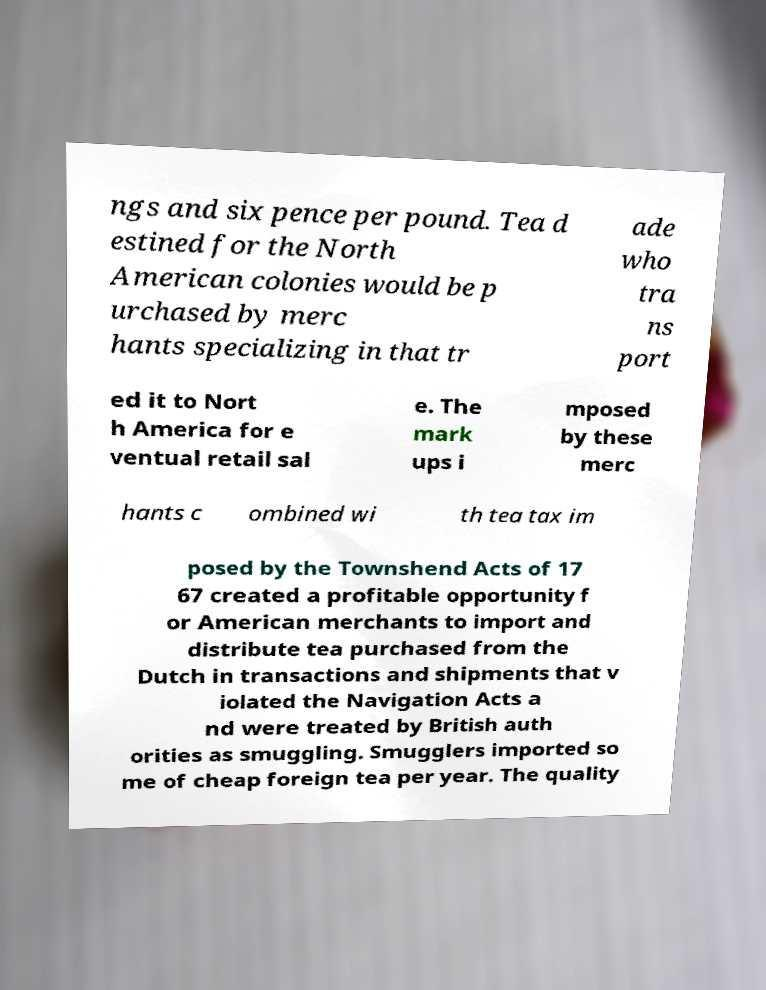For documentation purposes, I need the text within this image transcribed. Could you provide that? ngs and six pence per pound. Tea d estined for the North American colonies would be p urchased by merc hants specializing in that tr ade who tra ns port ed it to Nort h America for e ventual retail sal e. The mark ups i mposed by these merc hants c ombined wi th tea tax im posed by the Townshend Acts of 17 67 created a profitable opportunity f or American merchants to import and distribute tea purchased from the Dutch in transactions and shipments that v iolated the Navigation Acts a nd were treated by British auth orities as smuggling. Smugglers imported so me of cheap foreign tea per year. The quality 